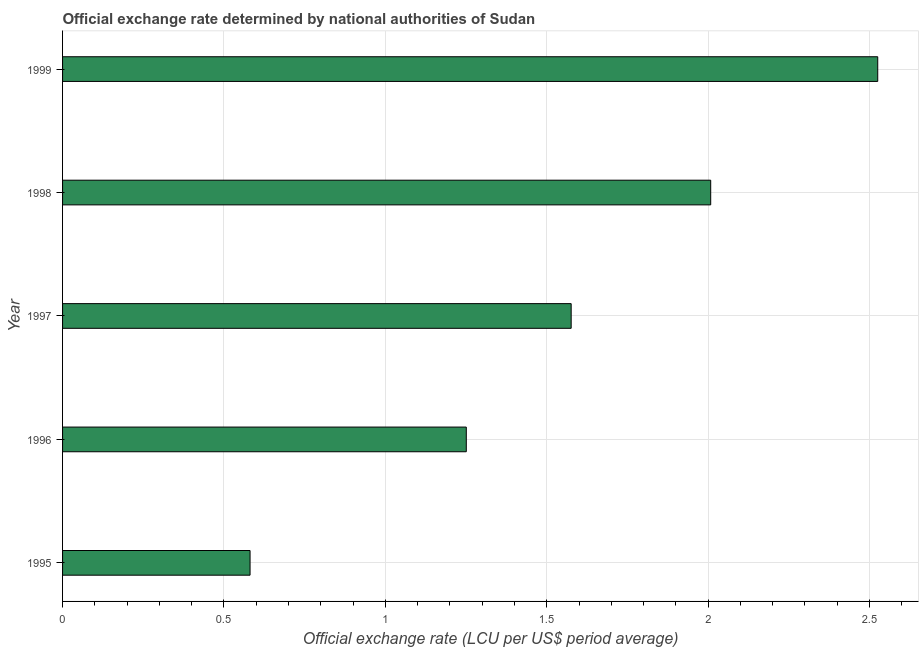Does the graph contain grids?
Make the answer very short. Yes. What is the title of the graph?
Provide a short and direct response. Official exchange rate determined by national authorities of Sudan. What is the label or title of the X-axis?
Provide a short and direct response. Official exchange rate (LCU per US$ period average). What is the label or title of the Y-axis?
Give a very brief answer. Year. What is the official exchange rate in 1996?
Your response must be concise. 1.25. Across all years, what is the maximum official exchange rate?
Keep it short and to the point. 2.53. Across all years, what is the minimum official exchange rate?
Your answer should be compact. 0.58. In which year was the official exchange rate maximum?
Your answer should be very brief. 1999. In which year was the official exchange rate minimum?
Your response must be concise. 1995. What is the sum of the official exchange rate?
Ensure brevity in your answer.  7.94. What is the difference between the official exchange rate in 1997 and 1999?
Offer a very short reply. -0.95. What is the average official exchange rate per year?
Give a very brief answer. 1.59. What is the median official exchange rate?
Your response must be concise. 1.58. Do a majority of the years between 1997 and 1996 (inclusive) have official exchange rate greater than 0.5 ?
Ensure brevity in your answer.  No. What is the ratio of the official exchange rate in 1995 to that in 1998?
Give a very brief answer. 0.29. Is the difference between the official exchange rate in 1998 and 1999 greater than the difference between any two years?
Your answer should be very brief. No. What is the difference between the highest and the second highest official exchange rate?
Provide a succinct answer. 0.52. What is the difference between the highest and the lowest official exchange rate?
Keep it short and to the point. 1.94. In how many years, is the official exchange rate greater than the average official exchange rate taken over all years?
Give a very brief answer. 2. What is the difference between two consecutive major ticks on the X-axis?
Provide a short and direct response. 0.5. Are the values on the major ticks of X-axis written in scientific E-notation?
Make the answer very short. No. What is the Official exchange rate (LCU per US$ period average) of 1995?
Make the answer very short. 0.58. What is the Official exchange rate (LCU per US$ period average) in 1996?
Provide a succinct answer. 1.25. What is the Official exchange rate (LCU per US$ period average) of 1997?
Give a very brief answer. 1.58. What is the Official exchange rate (LCU per US$ period average) in 1998?
Your response must be concise. 2.01. What is the Official exchange rate (LCU per US$ period average) of 1999?
Make the answer very short. 2.53. What is the difference between the Official exchange rate (LCU per US$ period average) in 1995 and 1996?
Your answer should be compact. -0.67. What is the difference between the Official exchange rate (LCU per US$ period average) in 1995 and 1997?
Provide a short and direct response. -0.99. What is the difference between the Official exchange rate (LCU per US$ period average) in 1995 and 1998?
Your answer should be very brief. -1.43. What is the difference between the Official exchange rate (LCU per US$ period average) in 1995 and 1999?
Give a very brief answer. -1.94. What is the difference between the Official exchange rate (LCU per US$ period average) in 1996 and 1997?
Give a very brief answer. -0.32. What is the difference between the Official exchange rate (LCU per US$ period average) in 1996 and 1998?
Give a very brief answer. -0.76. What is the difference between the Official exchange rate (LCU per US$ period average) in 1996 and 1999?
Ensure brevity in your answer.  -1.27. What is the difference between the Official exchange rate (LCU per US$ period average) in 1997 and 1998?
Make the answer very short. -0.43. What is the difference between the Official exchange rate (LCU per US$ period average) in 1997 and 1999?
Provide a succinct answer. -0.95. What is the difference between the Official exchange rate (LCU per US$ period average) in 1998 and 1999?
Your response must be concise. -0.52. What is the ratio of the Official exchange rate (LCU per US$ period average) in 1995 to that in 1996?
Ensure brevity in your answer.  0.46. What is the ratio of the Official exchange rate (LCU per US$ period average) in 1995 to that in 1997?
Give a very brief answer. 0.37. What is the ratio of the Official exchange rate (LCU per US$ period average) in 1995 to that in 1998?
Your answer should be very brief. 0.29. What is the ratio of the Official exchange rate (LCU per US$ period average) in 1995 to that in 1999?
Give a very brief answer. 0.23. What is the ratio of the Official exchange rate (LCU per US$ period average) in 1996 to that in 1997?
Provide a short and direct response. 0.79. What is the ratio of the Official exchange rate (LCU per US$ period average) in 1996 to that in 1998?
Your answer should be very brief. 0.62. What is the ratio of the Official exchange rate (LCU per US$ period average) in 1996 to that in 1999?
Ensure brevity in your answer.  0.49. What is the ratio of the Official exchange rate (LCU per US$ period average) in 1997 to that in 1998?
Offer a terse response. 0.79. What is the ratio of the Official exchange rate (LCU per US$ period average) in 1997 to that in 1999?
Keep it short and to the point. 0.62. What is the ratio of the Official exchange rate (LCU per US$ period average) in 1998 to that in 1999?
Provide a succinct answer. 0.8. 